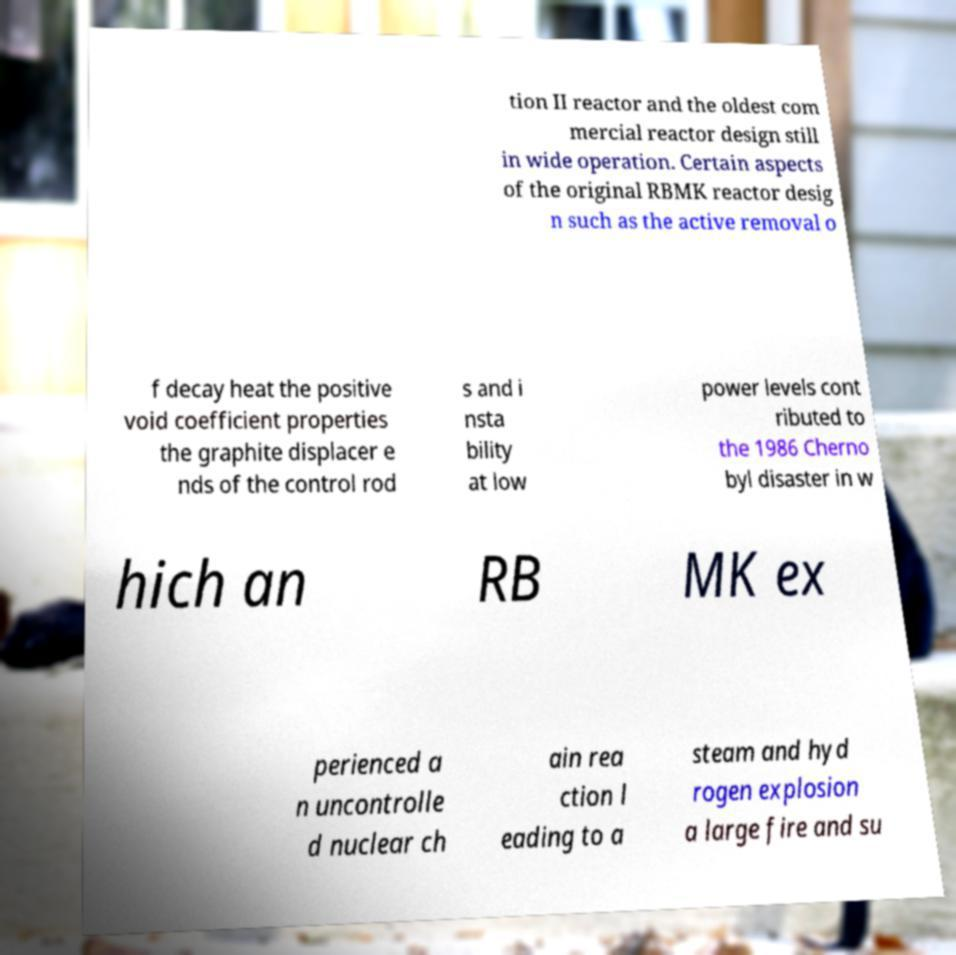Please identify and transcribe the text found in this image. tion II reactor and the oldest com mercial reactor design still in wide operation. Certain aspects of the original RBMK reactor desig n such as the active removal o f decay heat the positive void coefficient properties the graphite displacer e nds of the control rod s and i nsta bility at low power levels cont ributed to the 1986 Cherno byl disaster in w hich an RB MK ex perienced a n uncontrolle d nuclear ch ain rea ction l eading to a steam and hyd rogen explosion a large fire and su 